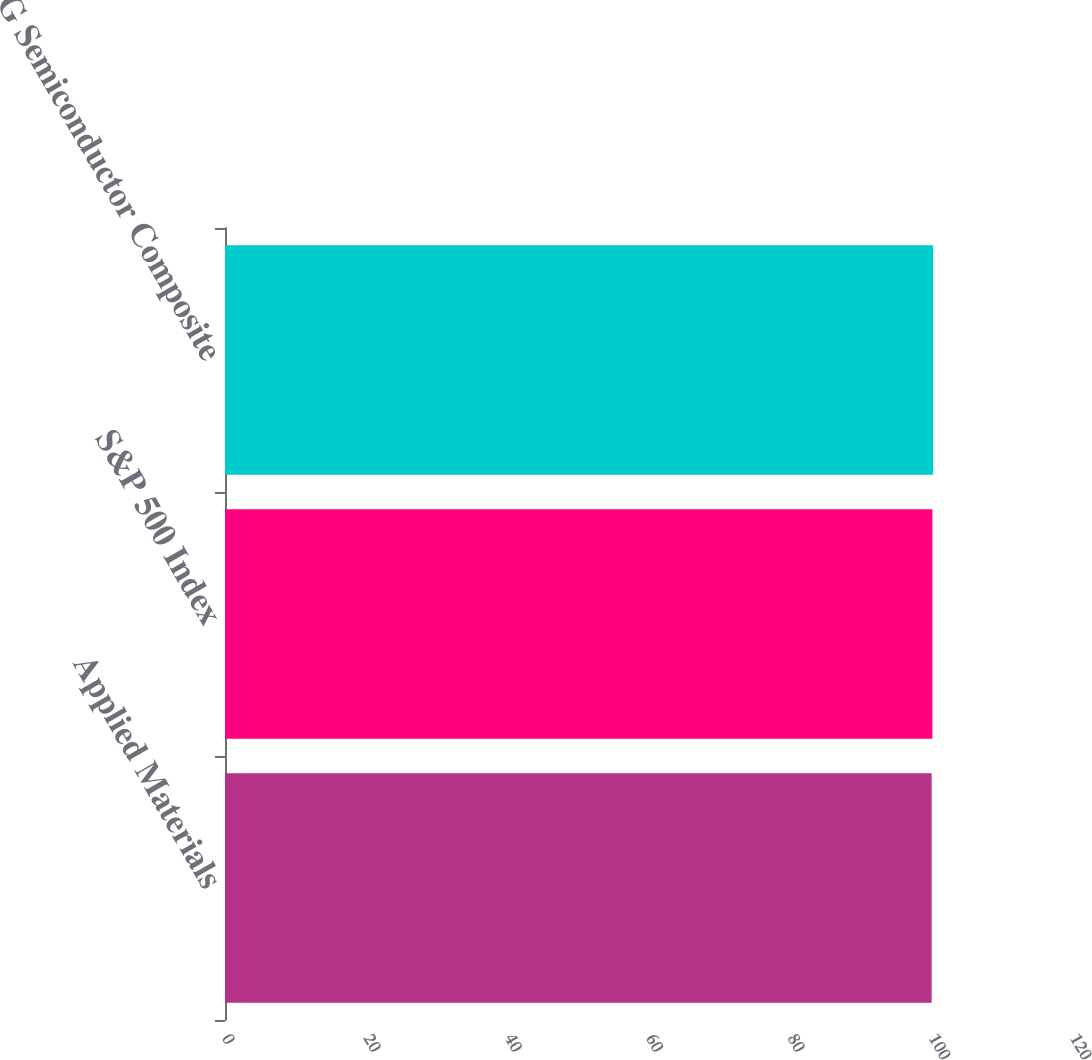<chart> <loc_0><loc_0><loc_500><loc_500><bar_chart><fcel>Applied Materials<fcel>S&P 500 Index<fcel>RDG Semiconductor Composite<nl><fcel>100<fcel>100.1<fcel>100.2<nl></chart> 